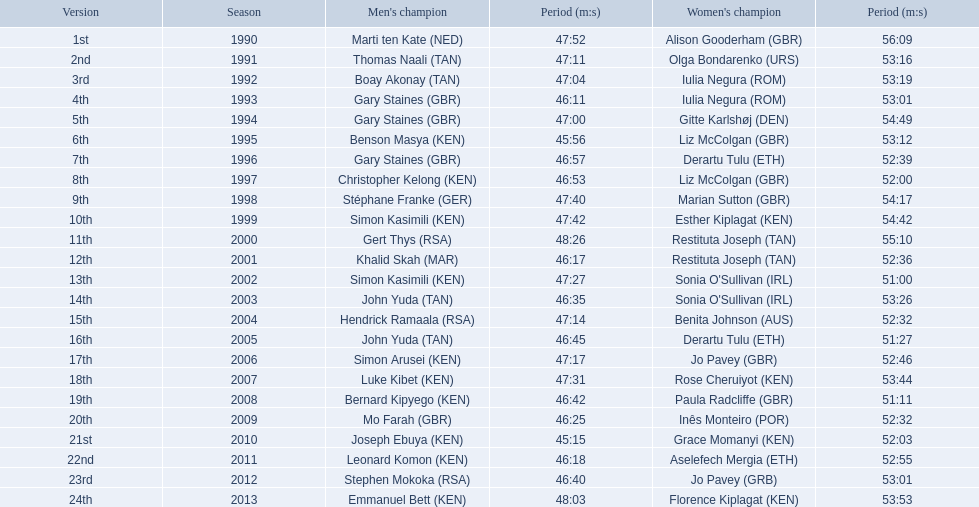Who were all the runners' times between 1990 and 2013? 47:52, 56:09, 47:11, 53:16, 47:04, 53:19, 46:11, 53:01, 47:00, 54:49, 45:56, 53:12, 46:57, 52:39, 46:53, 52:00, 47:40, 54:17, 47:42, 54:42, 48:26, 55:10, 46:17, 52:36, 47:27, 51:00, 46:35, 53:26, 47:14, 52:32, 46:45, 51:27, 47:17, 52:46, 47:31, 53:44, 46:42, 51:11, 46:25, 52:32, 45:15, 52:03, 46:18, 52:55, 46:40, 53:01, 48:03, 53:53. Which was the fastest time? 45:15. Who ran that time? Joseph Ebuya (KEN). Can you give me this table as a dict? {'header': ['Version', 'Season', "Men's champion", 'Period (m:s)', "Women's champion", 'Period (m:s)'], 'rows': [['1st', '1990', 'Marti ten Kate\xa0(NED)', '47:52', 'Alison Gooderham\xa0(GBR)', '56:09'], ['2nd', '1991', 'Thomas Naali\xa0(TAN)', '47:11', 'Olga Bondarenko\xa0(URS)', '53:16'], ['3rd', '1992', 'Boay Akonay\xa0(TAN)', '47:04', 'Iulia Negura\xa0(ROM)', '53:19'], ['4th', '1993', 'Gary Staines\xa0(GBR)', '46:11', 'Iulia Negura\xa0(ROM)', '53:01'], ['5th', '1994', 'Gary Staines\xa0(GBR)', '47:00', 'Gitte Karlshøj\xa0(DEN)', '54:49'], ['6th', '1995', 'Benson Masya\xa0(KEN)', '45:56', 'Liz McColgan\xa0(GBR)', '53:12'], ['7th', '1996', 'Gary Staines\xa0(GBR)', '46:57', 'Derartu Tulu\xa0(ETH)', '52:39'], ['8th', '1997', 'Christopher Kelong\xa0(KEN)', '46:53', 'Liz McColgan\xa0(GBR)', '52:00'], ['9th', '1998', 'Stéphane Franke\xa0(GER)', '47:40', 'Marian Sutton\xa0(GBR)', '54:17'], ['10th', '1999', 'Simon Kasimili\xa0(KEN)', '47:42', 'Esther Kiplagat\xa0(KEN)', '54:42'], ['11th', '2000', 'Gert Thys\xa0(RSA)', '48:26', 'Restituta Joseph\xa0(TAN)', '55:10'], ['12th', '2001', 'Khalid Skah\xa0(MAR)', '46:17', 'Restituta Joseph\xa0(TAN)', '52:36'], ['13th', '2002', 'Simon Kasimili\xa0(KEN)', '47:27', "Sonia O'Sullivan\xa0(IRL)", '51:00'], ['14th', '2003', 'John Yuda\xa0(TAN)', '46:35', "Sonia O'Sullivan\xa0(IRL)", '53:26'], ['15th', '2004', 'Hendrick Ramaala\xa0(RSA)', '47:14', 'Benita Johnson\xa0(AUS)', '52:32'], ['16th', '2005', 'John Yuda\xa0(TAN)', '46:45', 'Derartu Tulu\xa0(ETH)', '51:27'], ['17th', '2006', 'Simon Arusei\xa0(KEN)', '47:17', 'Jo Pavey\xa0(GBR)', '52:46'], ['18th', '2007', 'Luke Kibet\xa0(KEN)', '47:31', 'Rose Cheruiyot\xa0(KEN)', '53:44'], ['19th', '2008', 'Bernard Kipyego\xa0(KEN)', '46:42', 'Paula Radcliffe\xa0(GBR)', '51:11'], ['20th', '2009', 'Mo Farah\xa0(GBR)', '46:25', 'Inês Monteiro\xa0(POR)', '52:32'], ['21st', '2010', 'Joseph Ebuya\xa0(KEN)', '45:15', 'Grace Momanyi\xa0(KEN)', '52:03'], ['22nd', '2011', 'Leonard Komon\xa0(KEN)', '46:18', 'Aselefech Mergia\xa0(ETH)', '52:55'], ['23rd', '2012', 'Stephen Mokoka\xa0(RSA)', '46:40', 'Jo Pavey\xa0(GRB)', '53:01'], ['24th', '2013', 'Emmanuel Bett\xa0(KEN)', '48:03', 'Florence Kiplagat\xa0(KEN)', '53:53']]} 